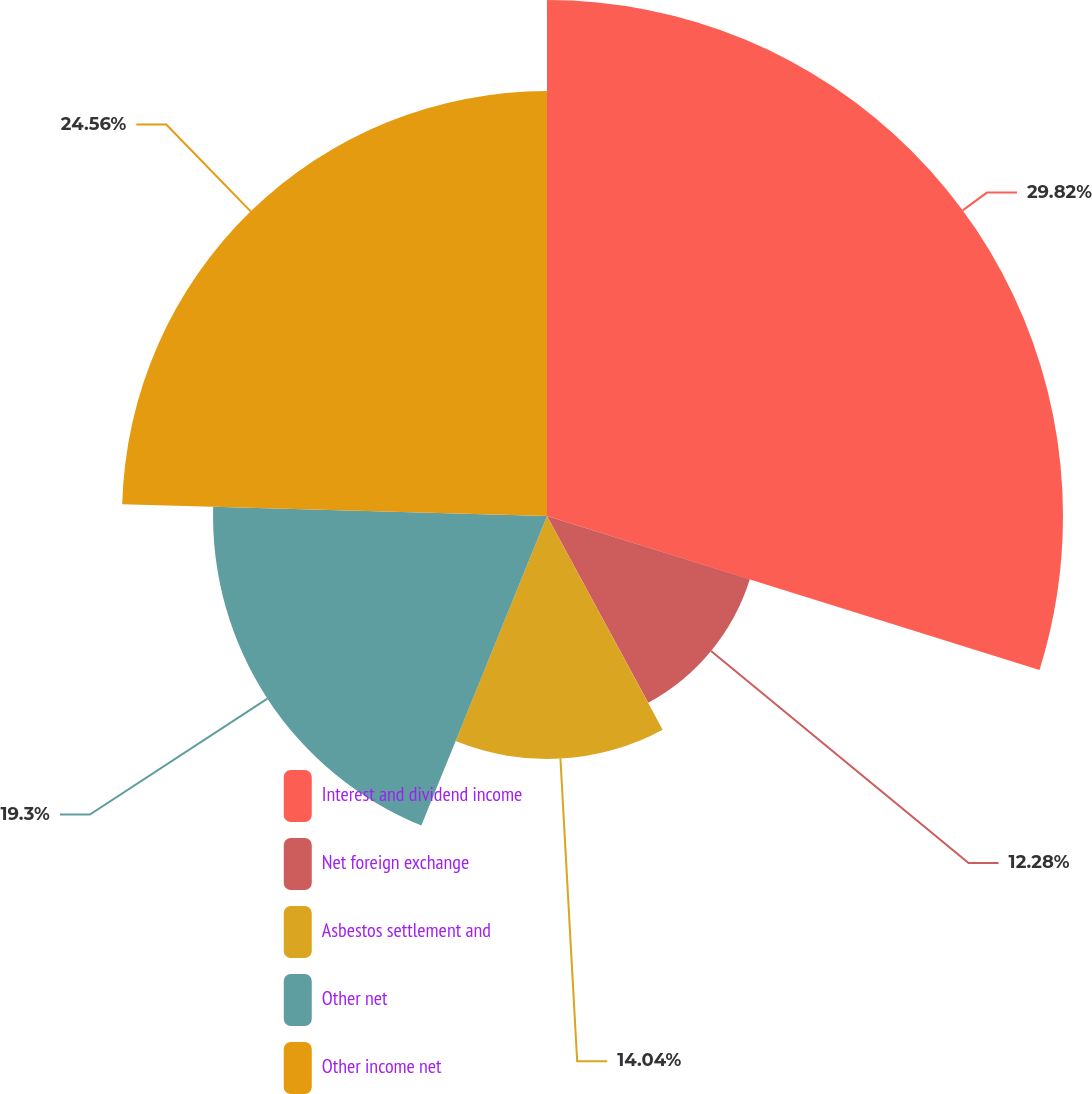Convert chart to OTSL. <chart><loc_0><loc_0><loc_500><loc_500><pie_chart><fcel>Interest and dividend income<fcel>Net foreign exchange<fcel>Asbestos settlement and<fcel>Other net<fcel>Other income net<nl><fcel>29.82%<fcel>12.28%<fcel>14.04%<fcel>19.3%<fcel>24.56%<nl></chart> 